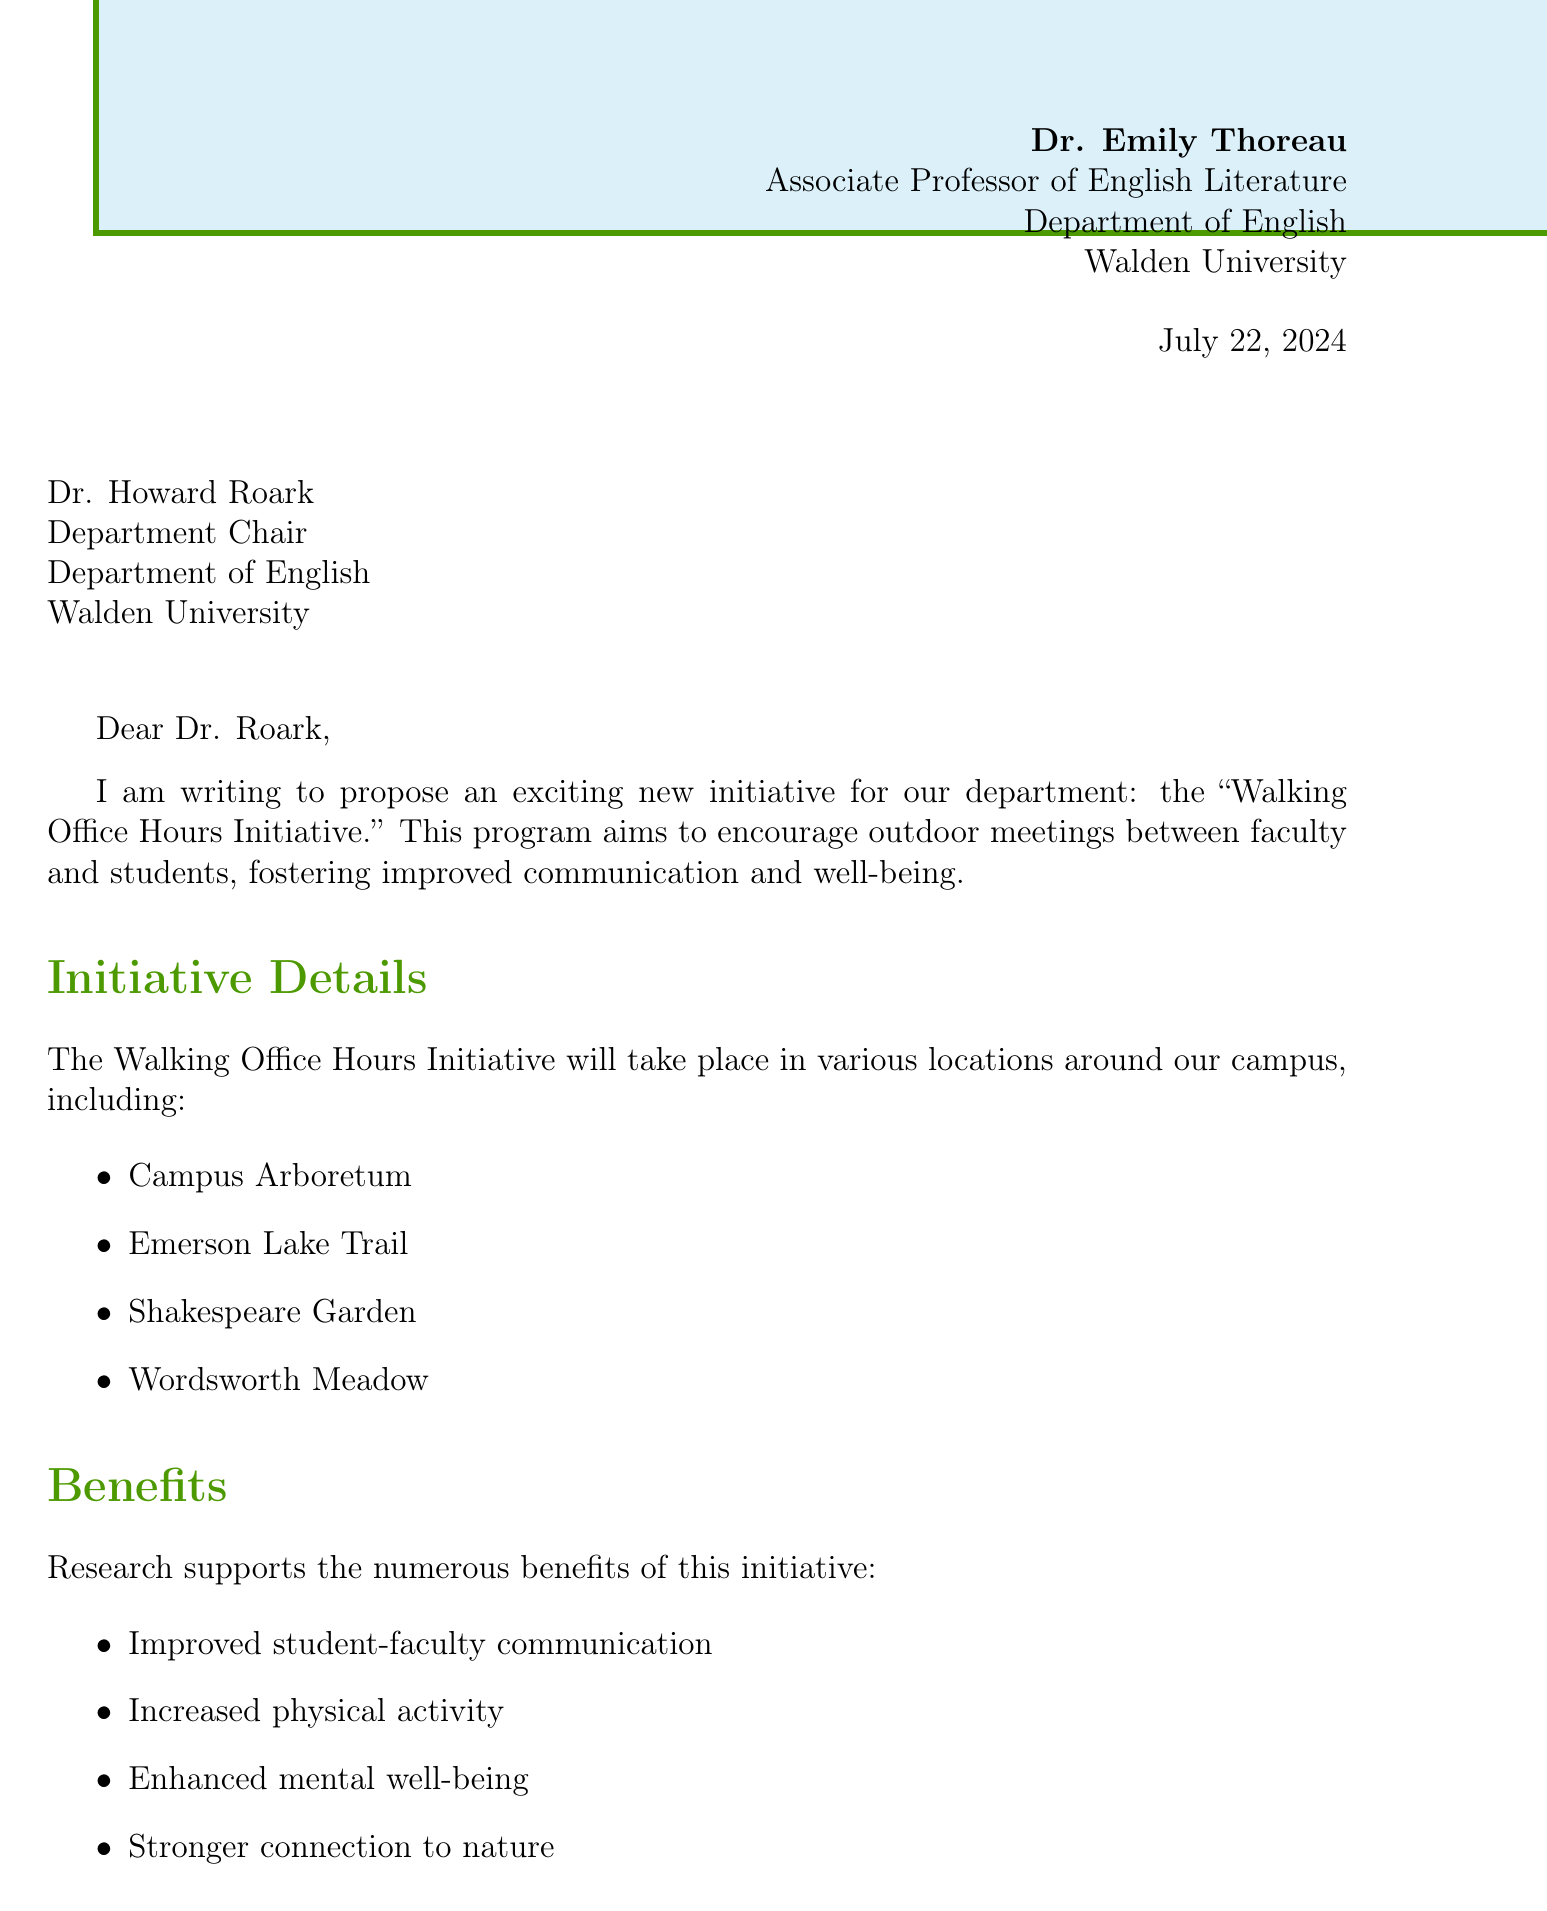What is the name of the initiative? The initiative is named the "Walking Office Hours Initiative" as stated in the document.
Answer: Walking Office Hours Initiative Who is the letter addressed to? The recipient of the letter is Dr. Howard Roark, mentioned in the recipient section.
Answer: Dr. Howard Roark What are the proposed locations for the initiative? The document lists several proposed locations for the initiative, such as the Campus Arboretum and Emerson Lake Trail.
Answer: Campus Arboretum, Emerson Lake Trail, Shakespeare Garden, Wordsworth Meadow What is the total budget for the initiative? The document outlines the total budget required for the initiative, which is clearly stated.
Answer: $850 When does the pilot phase start? The starting date for the pilot phase is provided in the implementation plan section of the letter.
Answer: September 1, 2023 What is one of the benefits mentioned in the letter? The document highlights several benefits of the initiative, one of which is improved communication.
Answer: Improved student-faculty communication What is the duration of the pilot phase? The letter specifies the length of the pilot phase in the implementation section.
Answer: 4 weeks What kind of training will faculty receive? The implementation plan mentions a specific type of training for faculty participating in the initiative.
Answer: Workshop on conducting effective walking meetings 